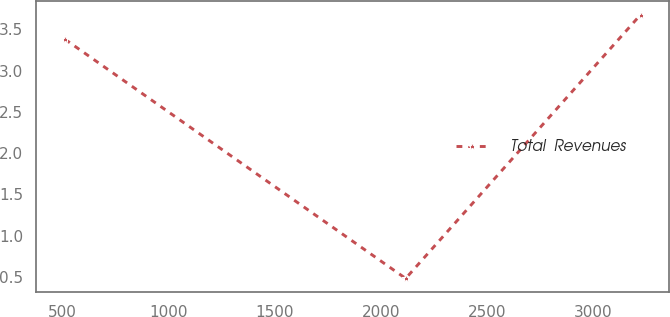<chart> <loc_0><loc_0><loc_500><loc_500><line_chart><ecel><fcel>Total  Revenues<nl><fcel>512.38<fcel>3.38<nl><fcel>2115.62<fcel>0.48<nl><fcel>3221.56<fcel>3.68<nl></chart> 